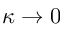<formula> <loc_0><loc_0><loc_500><loc_500>\kappa \rightarrow 0</formula> 